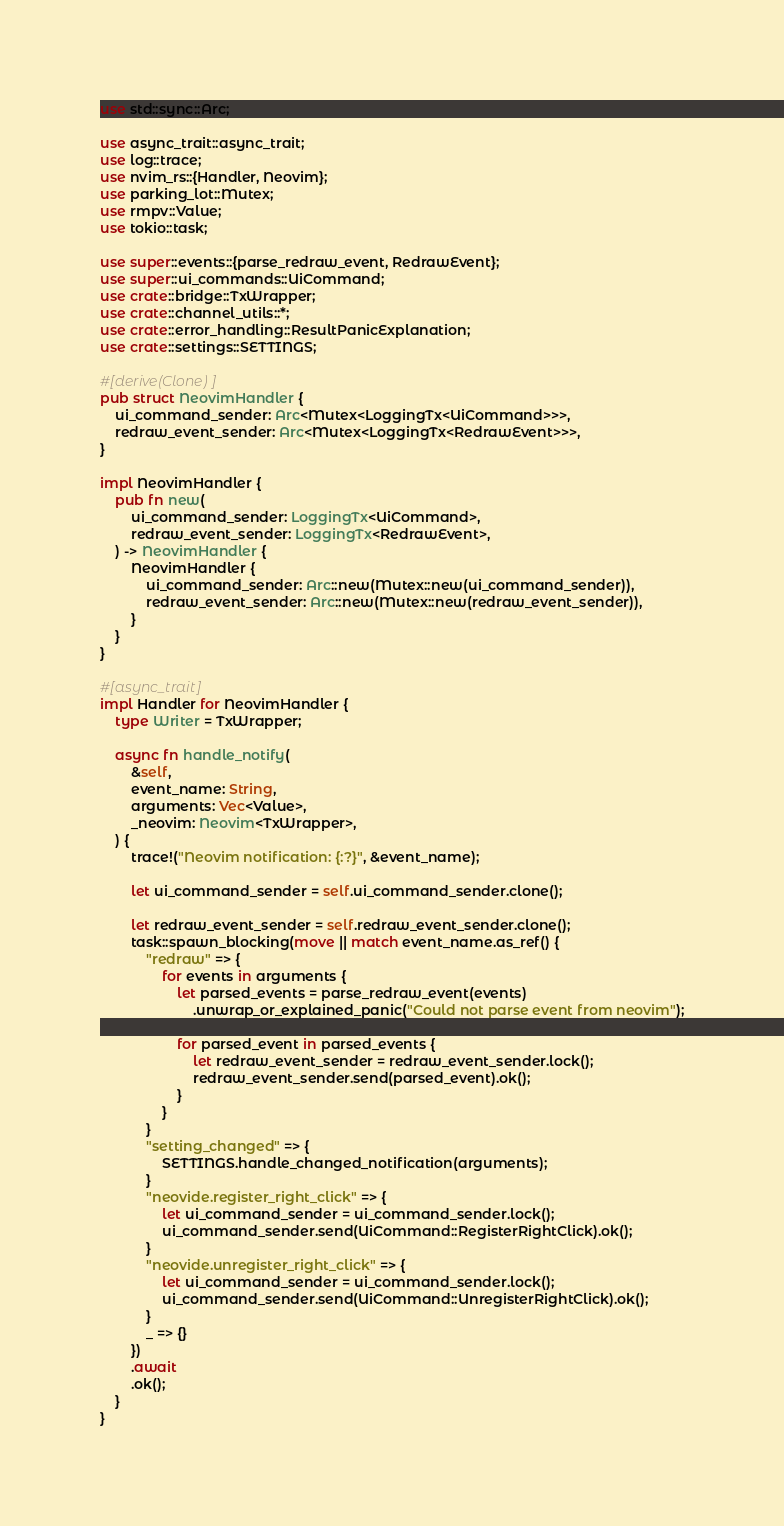Convert code to text. <code><loc_0><loc_0><loc_500><loc_500><_Rust_>use std::sync::Arc;

use async_trait::async_trait;
use log::trace;
use nvim_rs::{Handler, Neovim};
use parking_lot::Mutex;
use rmpv::Value;
use tokio::task;

use super::events::{parse_redraw_event, RedrawEvent};
use super::ui_commands::UiCommand;
use crate::bridge::TxWrapper;
use crate::channel_utils::*;
use crate::error_handling::ResultPanicExplanation;
use crate::settings::SETTINGS;

#[derive(Clone)]
pub struct NeovimHandler {
    ui_command_sender: Arc<Mutex<LoggingTx<UiCommand>>>,
    redraw_event_sender: Arc<Mutex<LoggingTx<RedrawEvent>>>,
}

impl NeovimHandler {
    pub fn new(
        ui_command_sender: LoggingTx<UiCommand>,
        redraw_event_sender: LoggingTx<RedrawEvent>,
    ) -> NeovimHandler {
        NeovimHandler {
            ui_command_sender: Arc::new(Mutex::new(ui_command_sender)),
            redraw_event_sender: Arc::new(Mutex::new(redraw_event_sender)),
        }
    }
}

#[async_trait]
impl Handler for NeovimHandler {
    type Writer = TxWrapper;

    async fn handle_notify(
        &self,
        event_name: String,
        arguments: Vec<Value>,
        _neovim: Neovim<TxWrapper>,
    ) {
        trace!("Neovim notification: {:?}", &event_name);

        let ui_command_sender = self.ui_command_sender.clone();

        let redraw_event_sender = self.redraw_event_sender.clone();
        task::spawn_blocking(move || match event_name.as_ref() {
            "redraw" => {
                for events in arguments {
                    let parsed_events = parse_redraw_event(events)
                        .unwrap_or_explained_panic("Could not parse event from neovim");

                    for parsed_event in parsed_events {
                        let redraw_event_sender = redraw_event_sender.lock();
                        redraw_event_sender.send(parsed_event).ok();
                    }
                }
            }
            "setting_changed" => {
                SETTINGS.handle_changed_notification(arguments);
            }
            "neovide.register_right_click" => {
                let ui_command_sender = ui_command_sender.lock();
                ui_command_sender.send(UiCommand::RegisterRightClick).ok();
            }
            "neovide.unregister_right_click" => {
                let ui_command_sender = ui_command_sender.lock();
                ui_command_sender.send(UiCommand::UnregisterRightClick).ok();
            }
            _ => {}
        })
        .await
        .ok();
    }
}
</code> 